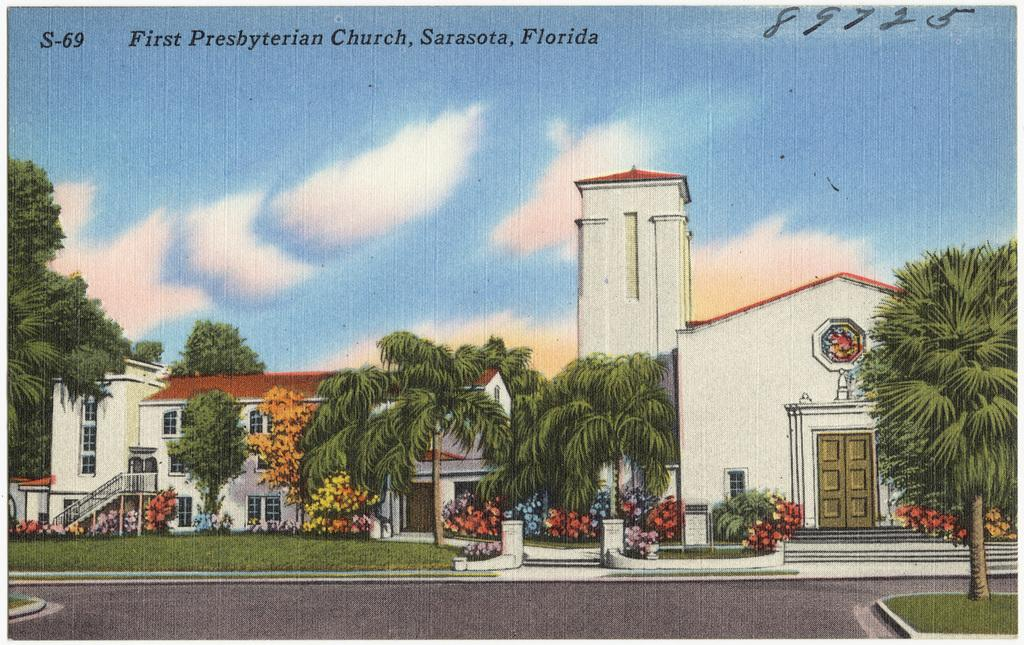What is the main subject of the image? The image contains a painting. What elements are depicted in the painting? The painting depicts trees, plants, grass, and buildings. What is visible in the sky at the top of the image? There are clouds in the sky at the top of the image. How many friends can be seen interacting with the writer in the painting? There are no friends or writers depicted in the painting; it only features trees, plants, grass, buildings, and clouds. What type of brass instrument is being played by the person in the painting? There are no brass instruments or people playing them in the painting; it only features trees, plants, grass, buildings, and clouds. 